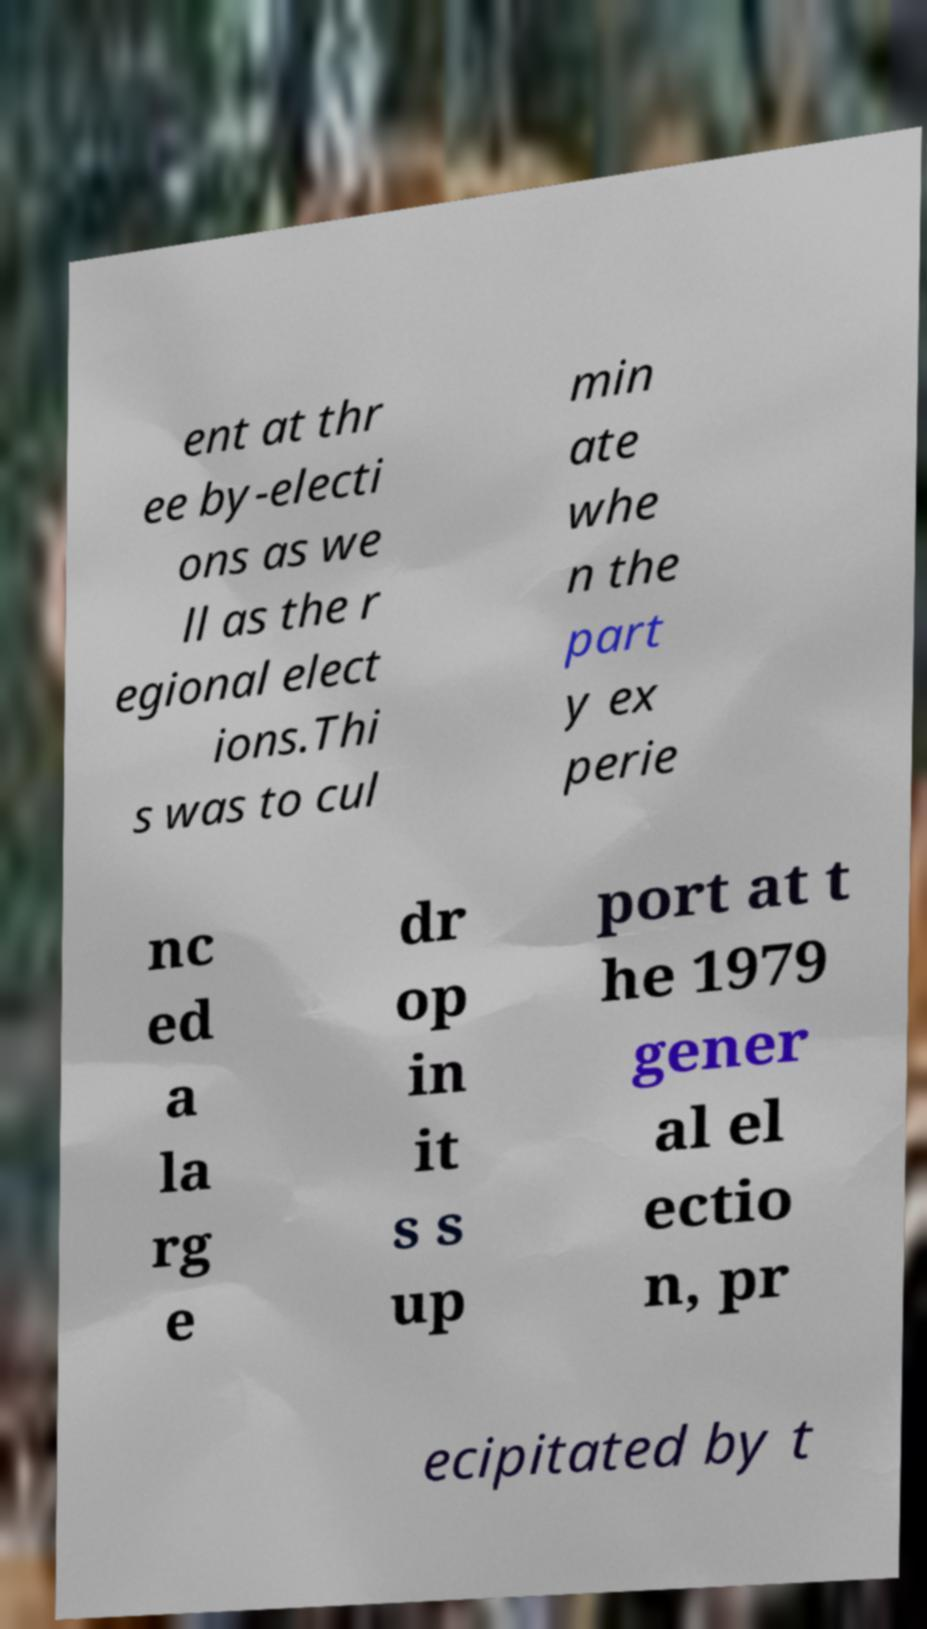Could you extract and type out the text from this image? ent at thr ee by-electi ons as we ll as the r egional elect ions.Thi s was to cul min ate whe n the part y ex perie nc ed a la rg e dr op in it s s up port at t he 1979 gener al el ectio n, pr ecipitated by t 